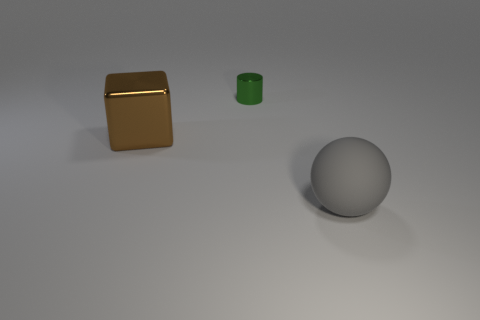Add 2 gray rubber blocks. How many objects exist? 5 Subtract all cylinders. How many objects are left? 2 Add 2 brown objects. How many brown objects are left? 3 Add 1 green objects. How many green objects exist? 2 Subtract 0 purple spheres. How many objects are left? 3 Subtract all big metallic things. Subtract all small yellow metallic things. How many objects are left? 2 